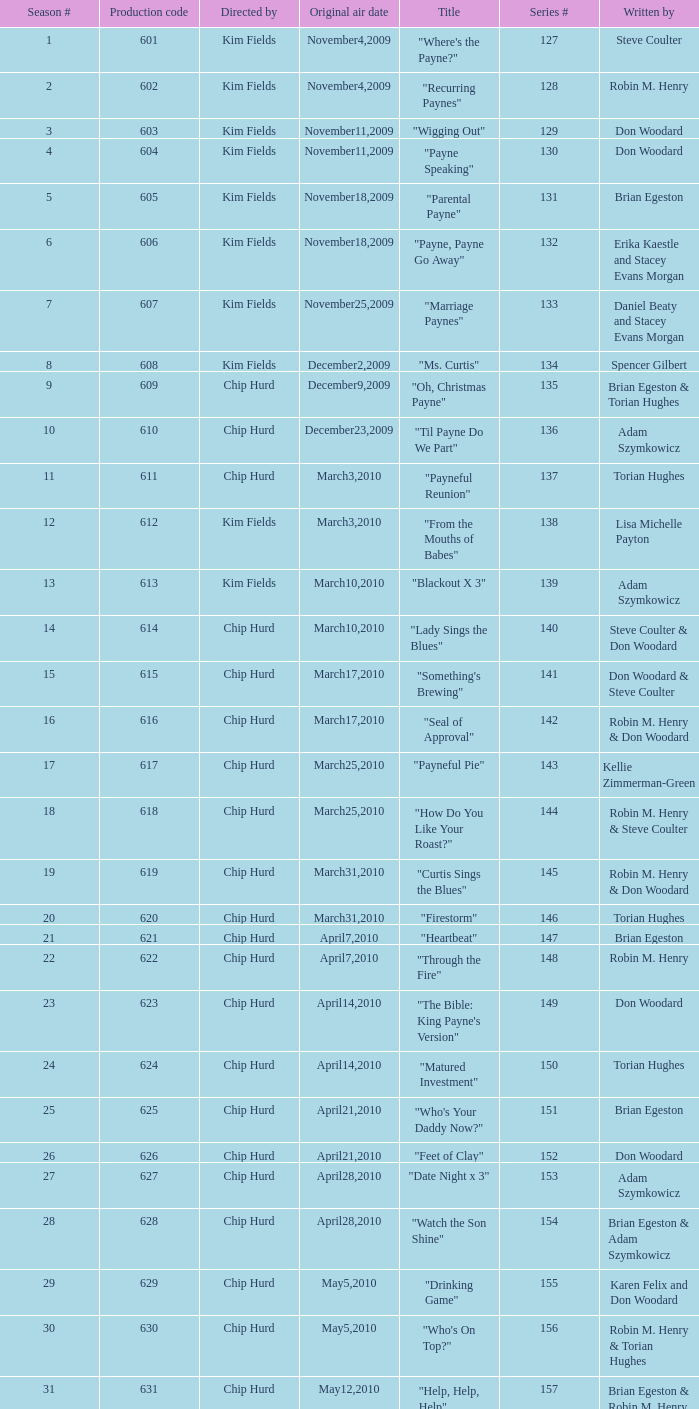What is the original air date of the episode written by Karen Felix and Don Woodard? May5,2010. 